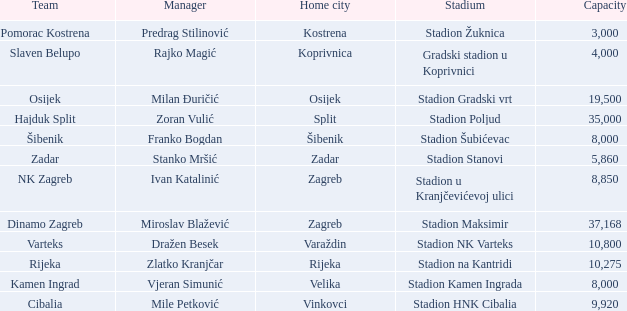What team has a home city of Velika? Kamen Ingrad. 